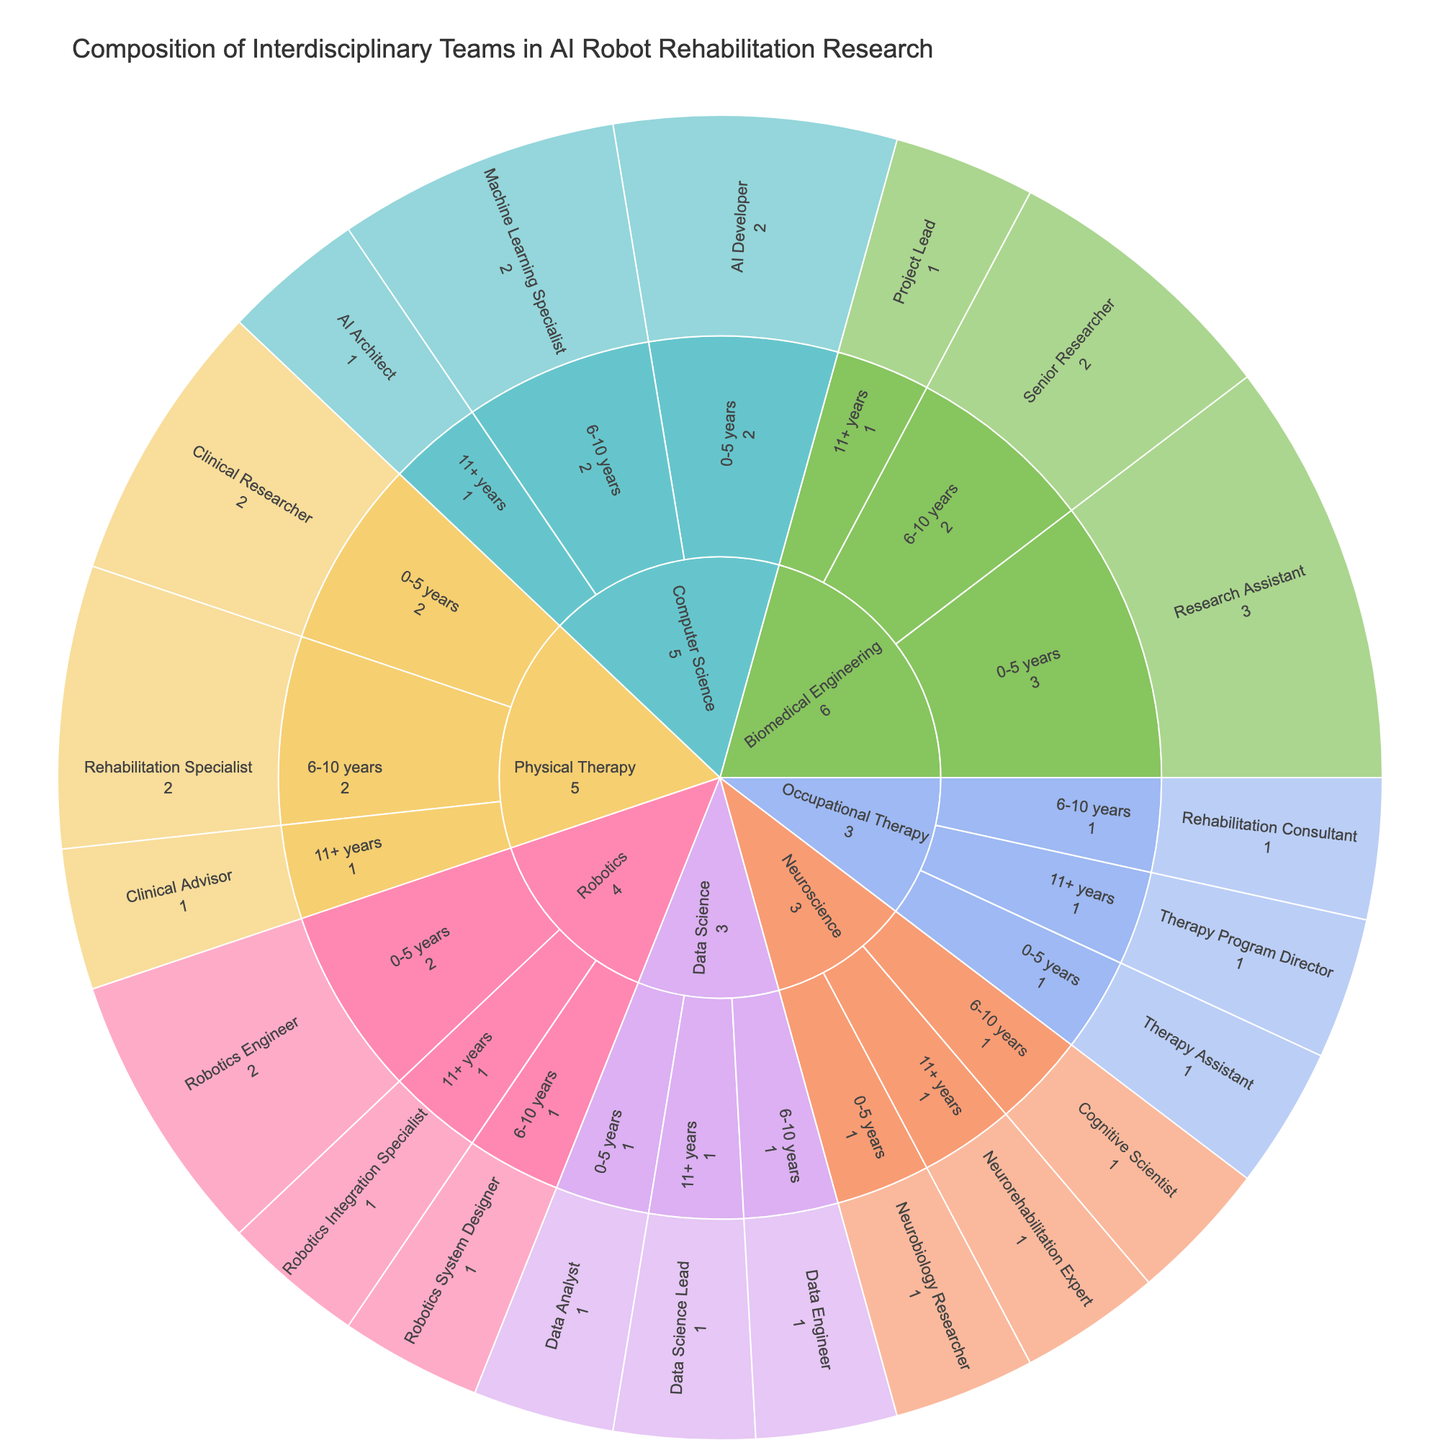Which expertise area has the highest number of individuals overall? Identify the top-level segments in the Sunburst Plot. Compare the total values for each expertise area. Biomedical Engineering has 3 + 2 + 1 = 6, Computer Science has 2 + 2 + 1 = 5, Robotics has 2 + 1 + 1 = 4, Physical Therapy has 2 + 2 + 1 = 5, Occupational Therapy has 1 + 1 + 1 = 3, Neuroscience has 1 + 1 + 1 = 3, and Data Science has 1 + 1 + 1 = 3. Biomedical Engineering has the highest overall count.
Answer: Biomedical Engineering Which role has the highest count within the Computer Science expertise area? Navigate to the Computer Science segment, and assess the counts for AI Developer, Machine Learning Specialist, and AI Architect. AI Developer has 2, Machine Learning Specialist has 2, and AI Architect has 1. The equal highest count is shared, but AI Developer appears first.
Answer: AI Developer How many total years of experience are represented in the Robotics expertise area? Sum the values for each segment under Robotics: 0-5 years has 2, 6-10 years has 1, and 11+ years has 1. Total: 2 + 1 + 1 = 4, representing 0-5, 6-10, and 11+ years.
Answer: 4 How does the number of individuals with 6-10 years of experience in Physical Therapy compare to those in Biomedical Engineering? Identify the counts for 6-10 years segments in Physical Therapy and Biomedical Engineering. Physical Therapy's Rehabilitation Specialist has 2, Biomedical Engineering's Senior Researcher has 2. Both counts are equal.
Answer: Equal Which expertise area has the least representation in individuals with 0-5 years of experience? Compare the 0-5 years segments for each expertise area. Occupational Therapy has Therapy Assistant with 1, which is the lowest number among them.
Answer: Occupational Therapy What's the total number of individuals with 11+ years of experience across all expertise areas? Sum the values for each 11+ years segment: Biomedical Engineering's Project Lead has 1, Computer Science's AI Architect has 1, Robotics' Robotics Integration Specialist has 1, Physical Therapy’s Clinical Advisor has 1, Occupational Therapy’s Therapy Program Director has 1, Neuroscience’s Neurorehabilitation Expert has 1, and Data Science’s Data Science Lead has 1. Total: 1 + 1 + 1 + 1 + 1 + 1 + 1 = 7.
Answer: 7 